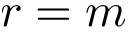<formula> <loc_0><loc_0><loc_500><loc_500>r = m</formula> 